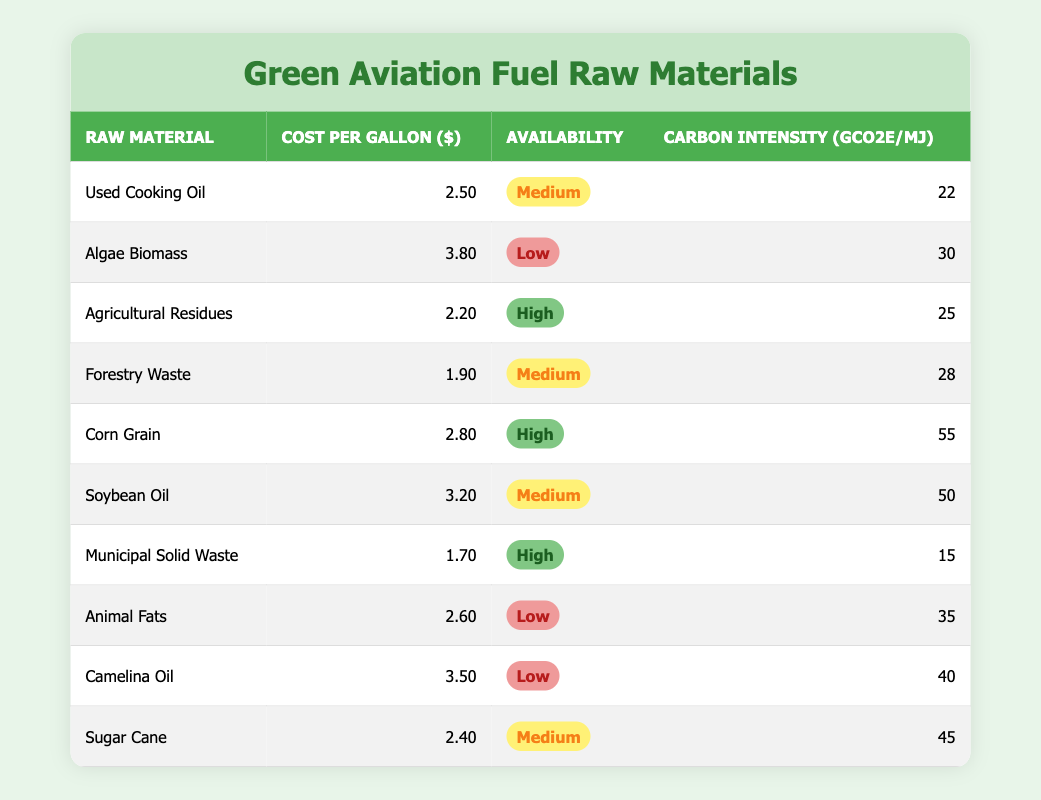What is the cost per gallon of the cheapest raw material listed? The cheapest raw material listed is Municipal Solid Waste, which costs $1.70 per gallon.
Answer: 1.70 What raw material has the highest carbon intensity? The raw material with the highest carbon intensity is Corn Grain, which has an intensity of 55 gCO2e/MJ.
Answer: 55 Is Sugar Cane more widely available than Animal Fats? The availability of Sugar Cane is categorized as Medium, while Animal Fats are categorized as Low, which means Sugar Cane is more widely available.
Answer: Yes What is the average cost per gallon of raw materials categorized as High availability? The raw materials categorized as High availability are Agricultural Residues, Corn Grain, and Municipal Solid Waste. Their costs per gallon are $2.20, $2.80, and $1.70. The sum is 2.20 + 2.80 + 1.70 = 6.70, and the average is 6.70 / 3 = 2.23.
Answer: 2.23 Which raw material has a medium availability and the lowest carbon intensity? The medium availability raw materials are Used Cooking Oil, Forestry Waste, Soybean Oil, and Sugar Cane. Among these, Used Cooking Oil has the lowest carbon intensity at 22 gCO2e/MJ.
Answer: Used Cooking Oil What is the total cost per gallon of all raw materials listed? To find the total cost per gallon, add up all individual costs: 2.50 + 3.80 + 2.20 + 1.90 + 2.80 + 3.20 + 1.70 + 2.60 + 3.50 + 2.40 = 24.10.
Answer: 24.10 Does any raw material have both Low availability and low carbon intensity? Algae Biomass and Animal Fats both have Low availability, but Animal Fats have a lower carbon intensity of 35 gCO2e/MJ compared to Algae Biomass with 30 gCO2e/MJ.
Answer: Yes What is the difference in cost per gallon between the most expensive and the least expensive raw materials? The most expensive raw material is Algae Biomass at $3.80 and the least expensive is Municipal Solid Waste at $1.70. The difference is 3.80 - 1.70 = 2.10.
Answer: 2.10 Which raw material has medium availability and the highest carbon intensity? The medium availability raw materials include Used Cooking Oil, Forestry Waste, Soybean Oil, and Sugar Cane. Among these, Soybean Oil has the highest carbon intensity at 50 gCO2e/MJ.
Answer: Soybean Oil 